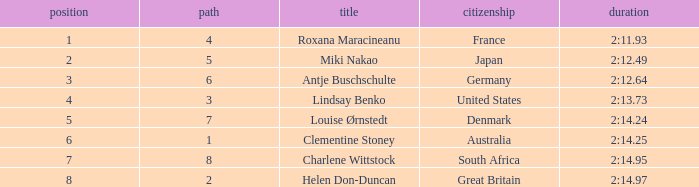What shows for nationality when there is a rank larger than 6, and a Time of 2:14.95? South Africa. Can you give me this table as a dict? {'header': ['position', 'path', 'title', 'citizenship', 'duration'], 'rows': [['1', '4', 'Roxana Maracineanu', 'France', '2:11.93'], ['2', '5', 'Miki Nakao', 'Japan', '2:12.49'], ['3', '6', 'Antje Buschschulte', 'Germany', '2:12.64'], ['4', '3', 'Lindsay Benko', 'United States', '2:13.73'], ['5', '7', 'Louise Ørnstedt', 'Denmark', '2:14.24'], ['6', '1', 'Clementine Stoney', 'Australia', '2:14.25'], ['7', '8', 'Charlene Wittstock', 'South Africa', '2:14.95'], ['8', '2', 'Helen Don-Duncan', 'Great Britain', '2:14.97']]} 